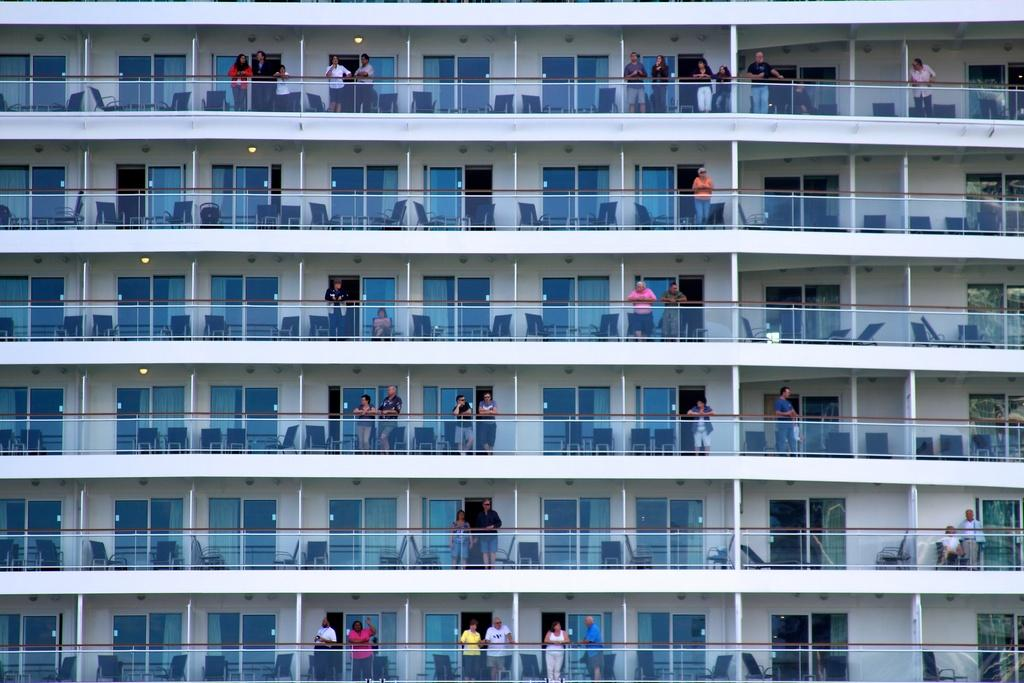What is the main structure visible in the image? There is a building in the image. Can you describe the people in the image? The people are standing in the balconies of the building. What type of hole can be seen in the building's facade in the image? There is no hole visible in the building's facade in the image. What kind of vessel is being used by the people in the image? The image does not show any vessels being used by the people. 